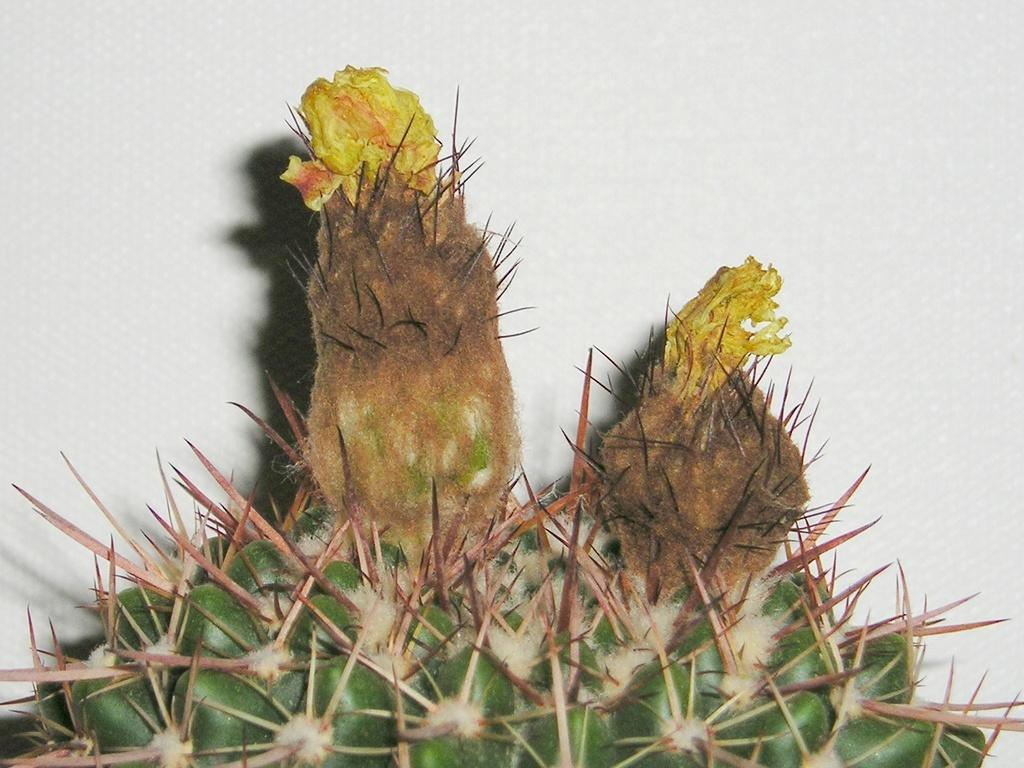What type of plant is in the image? There is a cactus plant in the image. What additional feature can be seen on the cactus plant? The cactus plant has flowers. What color are the flowers on the cactus plant? The flowers are yellow. What color is the background of the image? The background of the image is white. What type of noise can be heard coming from the church in the image? There is no church present in the image, so it's not possible to determine what, if any, noise might be heard. 